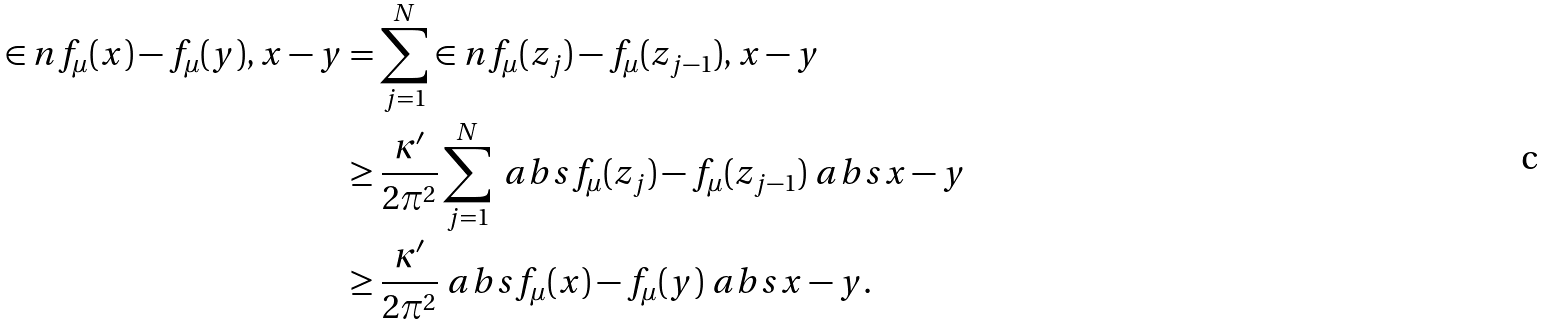Convert formula to latex. <formula><loc_0><loc_0><loc_500><loc_500>\in n { f _ { \mu } ( x ) - f _ { \mu } ( y ) , x - y } & = \sum _ { j = 1 } ^ { N } \in n { f _ { \mu } ( z _ { j } ) - f _ { \mu } ( z _ { j - 1 } ) , x - y } \\ & \geq \frac { \kappa ^ { \prime } } { 2 \pi ^ { 2 } } \sum _ { j = 1 } ^ { N } \ a b s { f _ { \mu } ( z _ { j } ) - f _ { \mu } ( z _ { j - 1 } ) } \ a b s { x - y } \\ & \geq \frac { \kappa ^ { \prime } } { 2 \pi ^ { 2 } } \ a b s { f _ { \mu } ( x ) - f _ { \mu } ( y ) } \ a b s { x - y } .</formula> 